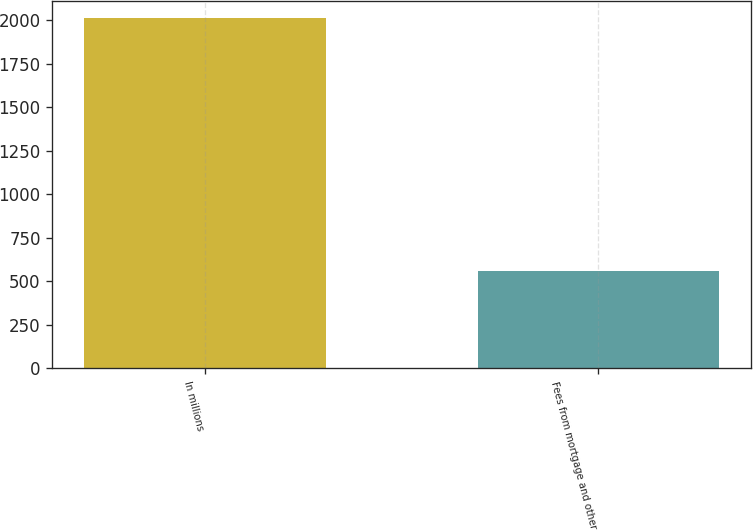Convert chart. <chart><loc_0><loc_0><loc_500><loc_500><bar_chart><fcel>In millions<fcel>Fees from mortgage and other<nl><fcel>2012<fcel>557<nl></chart> 